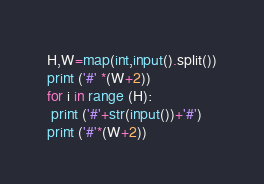Convert code to text. <code><loc_0><loc_0><loc_500><loc_500><_Python_>H,W=map(int,input().split())
print ('#' *(W+2))
for i in range (H):
 print ('#'+str(input())+'#')
print ('#'*(W+2))</code> 